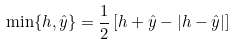Convert formula to latex. <formula><loc_0><loc_0><loc_500><loc_500>\min \{ h , \hat { y } \} = \frac { 1 } { 2 } \left [ h + \hat { y } - | h - \hat { y } | \right ]</formula> 